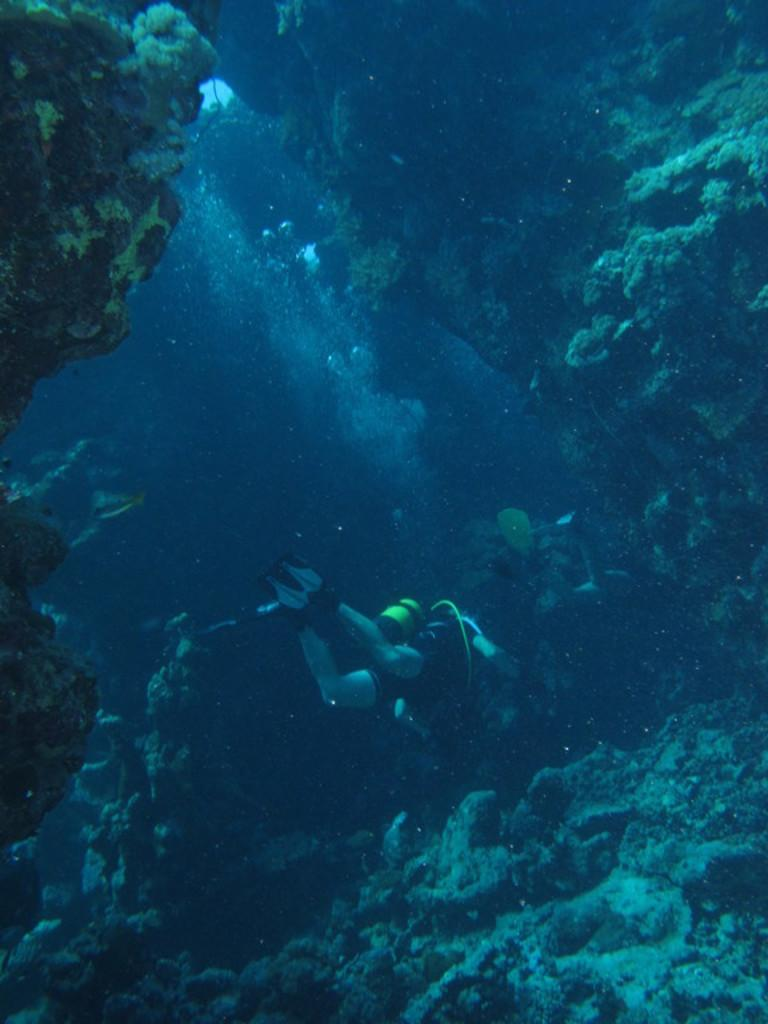Where was the image taken? The image is taken underwater. What is the main subject of the image? There is a person swimming in the center of the image. What else can be seen in the image besides the person swimming? There are stones visible in the image. What type of gate can be seen in the image? There is no gate present in the image, as it is taken underwater. Can you spot an owl in the image? There is no owl present in the image; it is taken underwater and features a person swimming and stones. 